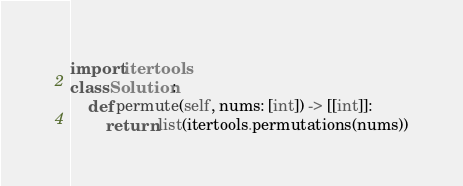<code> <loc_0><loc_0><loc_500><loc_500><_Python_>import itertools
class Solution:
    def permute(self, nums: [int]) -> [[int]]:
        return list(itertools.permutations(nums))</code> 